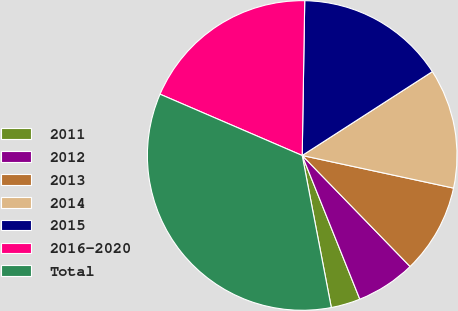Convert chart to OTSL. <chart><loc_0><loc_0><loc_500><loc_500><pie_chart><fcel>2011<fcel>2012<fcel>2013<fcel>2014<fcel>2015<fcel>2016-2020<fcel>Total<nl><fcel>3.06%<fcel>6.2%<fcel>9.35%<fcel>12.49%<fcel>15.63%<fcel>18.78%<fcel>34.49%<nl></chart> 